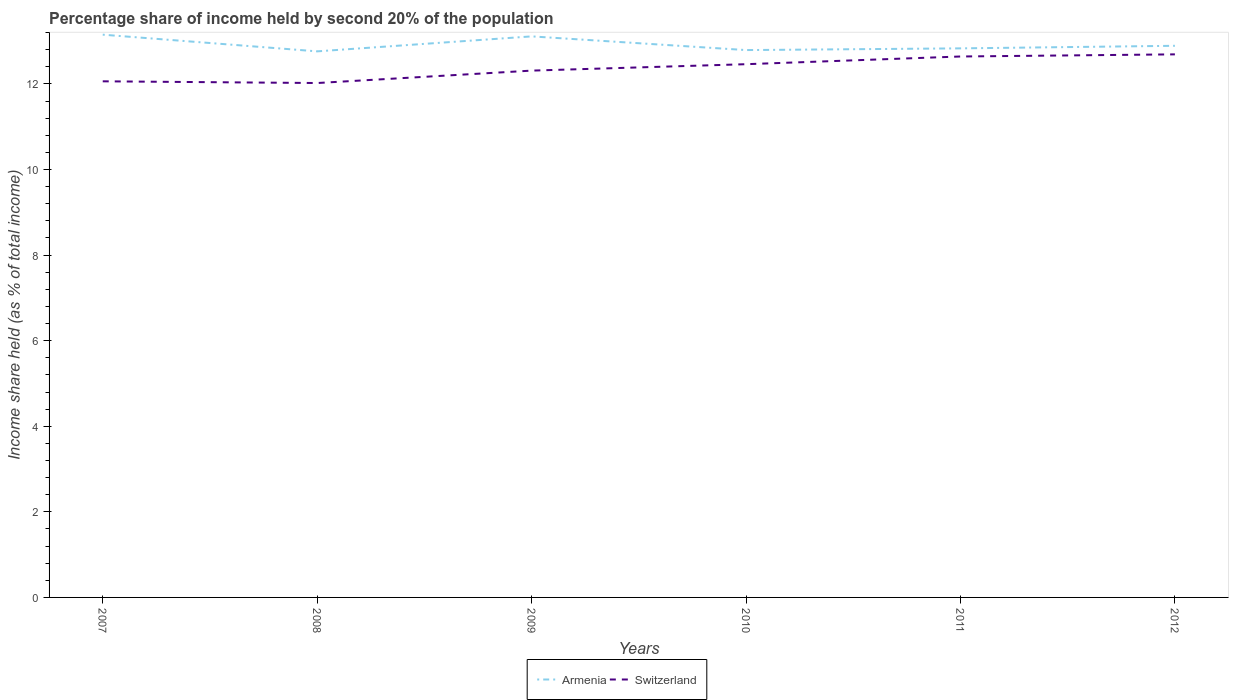How many different coloured lines are there?
Your answer should be compact. 2. Does the line corresponding to Switzerland intersect with the line corresponding to Armenia?
Offer a terse response. No. Is the number of lines equal to the number of legend labels?
Provide a succinct answer. Yes. Across all years, what is the maximum share of income held by second 20% of the population in Armenia?
Offer a terse response. 12.76. What is the total share of income held by second 20% of the population in Armenia in the graph?
Your answer should be compact. -0.35. What is the difference between the highest and the second highest share of income held by second 20% of the population in Switzerland?
Make the answer very short. 0.67. Is the share of income held by second 20% of the population in Armenia strictly greater than the share of income held by second 20% of the population in Switzerland over the years?
Keep it short and to the point. No. How many lines are there?
Your answer should be compact. 2. What is the title of the graph?
Provide a succinct answer. Percentage share of income held by second 20% of the population. Does "Bahamas" appear as one of the legend labels in the graph?
Your answer should be compact. No. What is the label or title of the X-axis?
Provide a succinct answer. Years. What is the label or title of the Y-axis?
Your answer should be very brief. Income share held (as % of total income). What is the Income share held (as % of total income) of Armenia in 2007?
Provide a short and direct response. 13.15. What is the Income share held (as % of total income) in Switzerland in 2007?
Ensure brevity in your answer.  12.06. What is the Income share held (as % of total income) in Armenia in 2008?
Your answer should be compact. 12.76. What is the Income share held (as % of total income) of Switzerland in 2008?
Offer a terse response. 12.02. What is the Income share held (as % of total income) in Armenia in 2009?
Your answer should be very brief. 13.11. What is the Income share held (as % of total income) of Switzerland in 2009?
Offer a terse response. 12.31. What is the Income share held (as % of total income) of Armenia in 2010?
Provide a succinct answer. 12.79. What is the Income share held (as % of total income) of Switzerland in 2010?
Offer a terse response. 12.46. What is the Income share held (as % of total income) of Armenia in 2011?
Provide a succinct answer. 12.83. What is the Income share held (as % of total income) in Switzerland in 2011?
Offer a terse response. 12.64. What is the Income share held (as % of total income) in Armenia in 2012?
Your answer should be very brief. 12.89. What is the Income share held (as % of total income) of Switzerland in 2012?
Make the answer very short. 12.69. Across all years, what is the maximum Income share held (as % of total income) in Armenia?
Ensure brevity in your answer.  13.15. Across all years, what is the maximum Income share held (as % of total income) of Switzerland?
Your answer should be compact. 12.69. Across all years, what is the minimum Income share held (as % of total income) of Armenia?
Give a very brief answer. 12.76. Across all years, what is the minimum Income share held (as % of total income) in Switzerland?
Provide a succinct answer. 12.02. What is the total Income share held (as % of total income) of Armenia in the graph?
Give a very brief answer. 77.53. What is the total Income share held (as % of total income) in Switzerland in the graph?
Provide a short and direct response. 74.18. What is the difference between the Income share held (as % of total income) of Armenia in 2007 and that in 2008?
Provide a succinct answer. 0.39. What is the difference between the Income share held (as % of total income) in Switzerland in 2007 and that in 2008?
Ensure brevity in your answer.  0.04. What is the difference between the Income share held (as % of total income) in Armenia in 2007 and that in 2009?
Offer a very short reply. 0.04. What is the difference between the Income share held (as % of total income) in Armenia in 2007 and that in 2010?
Ensure brevity in your answer.  0.36. What is the difference between the Income share held (as % of total income) in Armenia in 2007 and that in 2011?
Ensure brevity in your answer.  0.32. What is the difference between the Income share held (as % of total income) in Switzerland in 2007 and that in 2011?
Ensure brevity in your answer.  -0.58. What is the difference between the Income share held (as % of total income) of Armenia in 2007 and that in 2012?
Provide a short and direct response. 0.26. What is the difference between the Income share held (as % of total income) in Switzerland in 2007 and that in 2012?
Offer a terse response. -0.63. What is the difference between the Income share held (as % of total income) of Armenia in 2008 and that in 2009?
Ensure brevity in your answer.  -0.35. What is the difference between the Income share held (as % of total income) of Switzerland in 2008 and that in 2009?
Provide a succinct answer. -0.29. What is the difference between the Income share held (as % of total income) of Armenia in 2008 and that in 2010?
Your response must be concise. -0.03. What is the difference between the Income share held (as % of total income) of Switzerland in 2008 and that in 2010?
Offer a very short reply. -0.44. What is the difference between the Income share held (as % of total income) in Armenia in 2008 and that in 2011?
Provide a short and direct response. -0.07. What is the difference between the Income share held (as % of total income) of Switzerland in 2008 and that in 2011?
Offer a very short reply. -0.62. What is the difference between the Income share held (as % of total income) in Armenia in 2008 and that in 2012?
Provide a short and direct response. -0.13. What is the difference between the Income share held (as % of total income) in Switzerland in 2008 and that in 2012?
Your response must be concise. -0.67. What is the difference between the Income share held (as % of total income) of Armenia in 2009 and that in 2010?
Provide a succinct answer. 0.32. What is the difference between the Income share held (as % of total income) in Switzerland in 2009 and that in 2010?
Your answer should be very brief. -0.15. What is the difference between the Income share held (as % of total income) of Armenia in 2009 and that in 2011?
Your answer should be very brief. 0.28. What is the difference between the Income share held (as % of total income) of Switzerland in 2009 and that in 2011?
Make the answer very short. -0.33. What is the difference between the Income share held (as % of total income) of Armenia in 2009 and that in 2012?
Your answer should be very brief. 0.22. What is the difference between the Income share held (as % of total income) of Switzerland in 2009 and that in 2012?
Your answer should be compact. -0.38. What is the difference between the Income share held (as % of total income) of Armenia in 2010 and that in 2011?
Keep it short and to the point. -0.04. What is the difference between the Income share held (as % of total income) in Switzerland in 2010 and that in 2011?
Offer a very short reply. -0.18. What is the difference between the Income share held (as % of total income) of Switzerland in 2010 and that in 2012?
Offer a terse response. -0.23. What is the difference between the Income share held (as % of total income) of Armenia in 2011 and that in 2012?
Give a very brief answer. -0.06. What is the difference between the Income share held (as % of total income) in Switzerland in 2011 and that in 2012?
Provide a short and direct response. -0.05. What is the difference between the Income share held (as % of total income) of Armenia in 2007 and the Income share held (as % of total income) of Switzerland in 2008?
Your answer should be very brief. 1.13. What is the difference between the Income share held (as % of total income) in Armenia in 2007 and the Income share held (as % of total income) in Switzerland in 2009?
Provide a short and direct response. 0.84. What is the difference between the Income share held (as % of total income) of Armenia in 2007 and the Income share held (as % of total income) of Switzerland in 2010?
Your answer should be compact. 0.69. What is the difference between the Income share held (as % of total income) in Armenia in 2007 and the Income share held (as % of total income) in Switzerland in 2011?
Make the answer very short. 0.51. What is the difference between the Income share held (as % of total income) of Armenia in 2007 and the Income share held (as % of total income) of Switzerland in 2012?
Your answer should be very brief. 0.46. What is the difference between the Income share held (as % of total income) in Armenia in 2008 and the Income share held (as % of total income) in Switzerland in 2009?
Give a very brief answer. 0.45. What is the difference between the Income share held (as % of total income) of Armenia in 2008 and the Income share held (as % of total income) of Switzerland in 2010?
Ensure brevity in your answer.  0.3. What is the difference between the Income share held (as % of total income) of Armenia in 2008 and the Income share held (as % of total income) of Switzerland in 2011?
Give a very brief answer. 0.12. What is the difference between the Income share held (as % of total income) in Armenia in 2008 and the Income share held (as % of total income) in Switzerland in 2012?
Provide a succinct answer. 0.07. What is the difference between the Income share held (as % of total income) in Armenia in 2009 and the Income share held (as % of total income) in Switzerland in 2010?
Offer a very short reply. 0.65. What is the difference between the Income share held (as % of total income) in Armenia in 2009 and the Income share held (as % of total income) in Switzerland in 2011?
Your answer should be very brief. 0.47. What is the difference between the Income share held (as % of total income) in Armenia in 2009 and the Income share held (as % of total income) in Switzerland in 2012?
Keep it short and to the point. 0.42. What is the difference between the Income share held (as % of total income) in Armenia in 2010 and the Income share held (as % of total income) in Switzerland in 2011?
Provide a short and direct response. 0.15. What is the difference between the Income share held (as % of total income) of Armenia in 2010 and the Income share held (as % of total income) of Switzerland in 2012?
Offer a very short reply. 0.1. What is the difference between the Income share held (as % of total income) in Armenia in 2011 and the Income share held (as % of total income) in Switzerland in 2012?
Keep it short and to the point. 0.14. What is the average Income share held (as % of total income) in Armenia per year?
Ensure brevity in your answer.  12.92. What is the average Income share held (as % of total income) in Switzerland per year?
Give a very brief answer. 12.36. In the year 2007, what is the difference between the Income share held (as % of total income) in Armenia and Income share held (as % of total income) in Switzerland?
Provide a succinct answer. 1.09. In the year 2008, what is the difference between the Income share held (as % of total income) in Armenia and Income share held (as % of total income) in Switzerland?
Offer a terse response. 0.74. In the year 2009, what is the difference between the Income share held (as % of total income) in Armenia and Income share held (as % of total income) in Switzerland?
Offer a very short reply. 0.8. In the year 2010, what is the difference between the Income share held (as % of total income) of Armenia and Income share held (as % of total income) of Switzerland?
Keep it short and to the point. 0.33. In the year 2011, what is the difference between the Income share held (as % of total income) in Armenia and Income share held (as % of total income) in Switzerland?
Give a very brief answer. 0.19. In the year 2012, what is the difference between the Income share held (as % of total income) in Armenia and Income share held (as % of total income) in Switzerland?
Provide a short and direct response. 0.2. What is the ratio of the Income share held (as % of total income) of Armenia in 2007 to that in 2008?
Your answer should be compact. 1.03. What is the ratio of the Income share held (as % of total income) in Switzerland in 2007 to that in 2009?
Your answer should be compact. 0.98. What is the ratio of the Income share held (as % of total income) of Armenia in 2007 to that in 2010?
Your response must be concise. 1.03. What is the ratio of the Income share held (as % of total income) of Switzerland in 2007 to that in 2010?
Ensure brevity in your answer.  0.97. What is the ratio of the Income share held (as % of total income) in Armenia in 2007 to that in 2011?
Provide a short and direct response. 1.02. What is the ratio of the Income share held (as % of total income) in Switzerland in 2007 to that in 2011?
Offer a very short reply. 0.95. What is the ratio of the Income share held (as % of total income) of Armenia in 2007 to that in 2012?
Ensure brevity in your answer.  1.02. What is the ratio of the Income share held (as % of total income) in Switzerland in 2007 to that in 2012?
Ensure brevity in your answer.  0.95. What is the ratio of the Income share held (as % of total income) of Armenia in 2008 to that in 2009?
Your response must be concise. 0.97. What is the ratio of the Income share held (as % of total income) of Switzerland in 2008 to that in 2009?
Provide a short and direct response. 0.98. What is the ratio of the Income share held (as % of total income) of Switzerland in 2008 to that in 2010?
Your response must be concise. 0.96. What is the ratio of the Income share held (as % of total income) in Armenia in 2008 to that in 2011?
Give a very brief answer. 0.99. What is the ratio of the Income share held (as % of total income) in Switzerland in 2008 to that in 2011?
Offer a terse response. 0.95. What is the ratio of the Income share held (as % of total income) of Armenia in 2008 to that in 2012?
Make the answer very short. 0.99. What is the ratio of the Income share held (as % of total income) in Switzerland in 2008 to that in 2012?
Ensure brevity in your answer.  0.95. What is the ratio of the Income share held (as % of total income) of Armenia in 2009 to that in 2010?
Provide a short and direct response. 1.02. What is the ratio of the Income share held (as % of total income) of Switzerland in 2009 to that in 2010?
Make the answer very short. 0.99. What is the ratio of the Income share held (as % of total income) in Armenia in 2009 to that in 2011?
Ensure brevity in your answer.  1.02. What is the ratio of the Income share held (as % of total income) in Switzerland in 2009 to that in 2011?
Your response must be concise. 0.97. What is the ratio of the Income share held (as % of total income) of Armenia in 2009 to that in 2012?
Offer a terse response. 1.02. What is the ratio of the Income share held (as % of total income) in Switzerland in 2009 to that in 2012?
Provide a short and direct response. 0.97. What is the ratio of the Income share held (as % of total income) of Switzerland in 2010 to that in 2011?
Your response must be concise. 0.99. What is the ratio of the Income share held (as % of total income) in Armenia in 2010 to that in 2012?
Ensure brevity in your answer.  0.99. What is the ratio of the Income share held (as % of total income) in Switzerland in 2010 to that in 2012?
Give a very brief answer. 0.98. What is the ratio of the Income share held (as % of total income) of Armenia in 2011 to that in 2012?
Your answer should be very brief. 1. What is the difference between the highest and the second highest Income share held (as % of total income) in Switzerland?
Keep it short and to the point. 0.05. What is the difference between the highest and the lowest Income share held (as % of total income) in Armenia?
Your answer should be very brief. 0.39. What is the difference between the highest and the lowest Income share held (as % of total income) of Switzerland?
Keep it short and to the point. 0.67. 